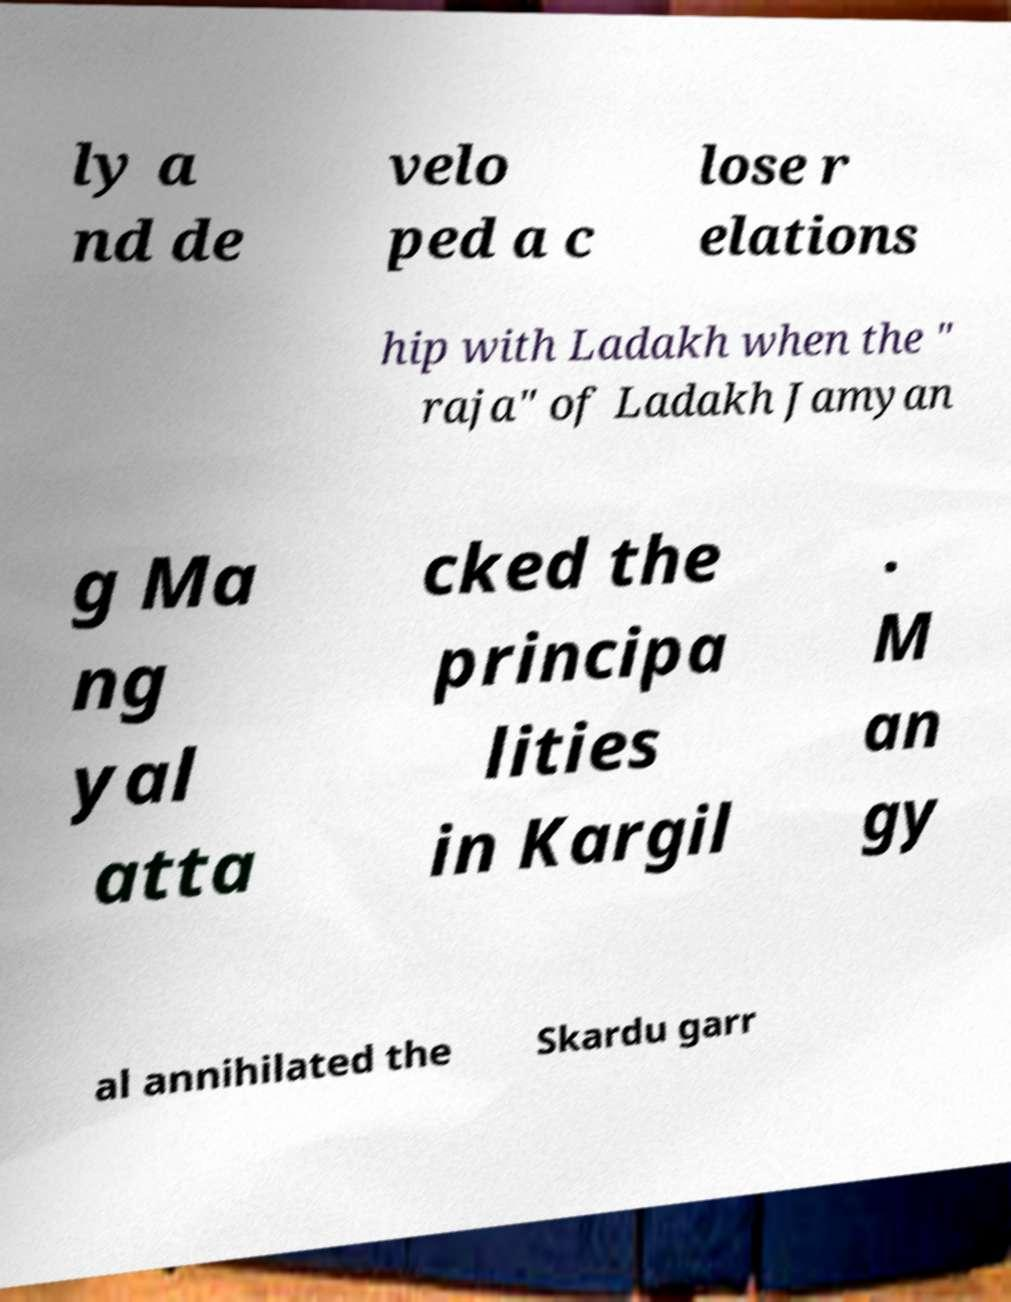What messages or text are displayed in this image? I need them in a readable, typed format. ly a nd de velo ped a c lose r elations hip with Ladakh when the " raja" of Ladakh Jamyan g Ma ng yal atta cked the principa lities in Kargil . M an gy al annihilated the Skardu garr 